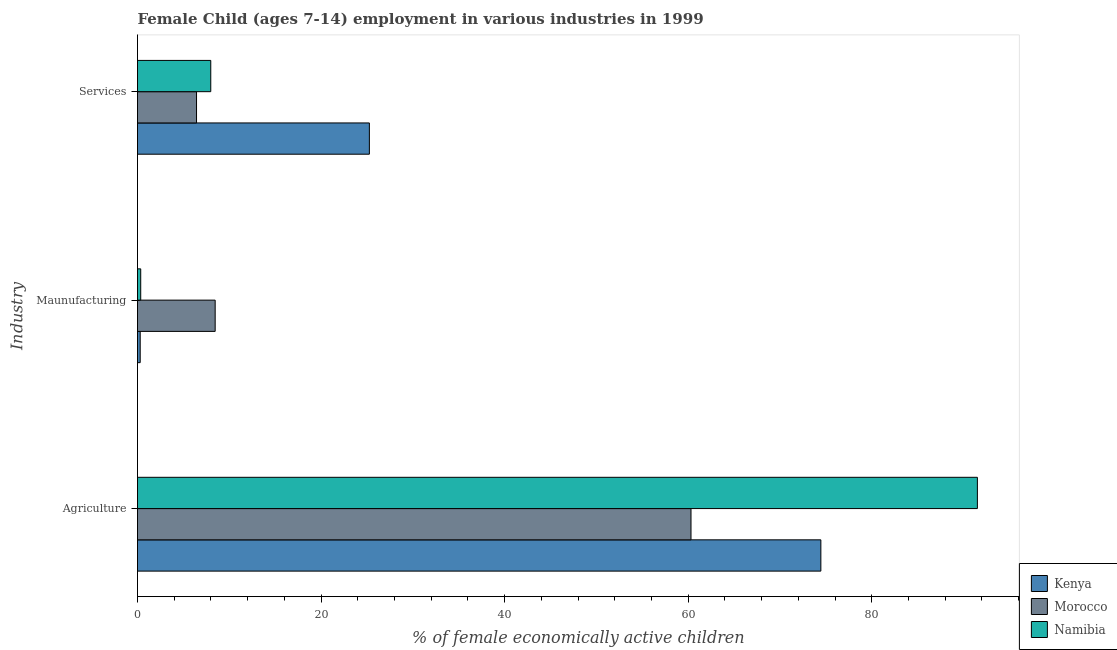How many different coloured bars are there?
Make the answer very short. 3. Are the number of bars on each tick of the Y-axis equal?
Offer a very short reply. Yes. How many bars are there on the 2nd tick from the bottom?
Your answer should be very brief. 3. What is the label of the 3rd group of bars from the top?
Your response must be concise. Agriculture. What is the percentage of economically active children in services in Namibia?
Offer a very short reply. 7.98. Across all countries, what is the maximum percentage of economically active children in manufacturing?
Offer a terse response. 8.46. Across all countries, what is the minimum percentage of economically active children in manufacturing?
Your answer should be compact. 0.29. In which country was the percentage of economically active children in manufacturing maximum?
Your answer should be very brief. Morocco. In which country was the percentage of economically active children in services minimum?
Your answer should be very brief. Morocco. What is the total percentage of economically active children in agriculture in the graph?
Offer a very short reply. 226.25. What is the difference between the percentage of economically active children in manufacturing in Kenya and that in Namibia?
Give a very brief answer. -0.06. What is the difference between the percentage of economically active children in services in Namibia and the percentage of economically active children in agriculture in Morocco?
Your response must be concise. -52.32. What is the average percentage of economically active children in services per country?
Ensure brevity in your answer.  13.22. What is the difference between the percentage of economically active children in manufacturing and percentage of economically active children in services in Kenya?
Offer a terse response. -24.97. What is the ratio of the percentage of economically active children in manufacturing in Kenya to that in Namibia?
Provide a short and direct response. 0.84. Is the difference between the percentage of economically active children in services in Kenya and Namibia greater than the difference between the percentage of economically active children in agriculture in Kenya and Namibia?
Offer a very short reply. Yes. What is the difference between the highest and the second highest percentage of economically active children in services?
Offer a very short reply. 17.28. What is the difference between the highest and the lowest percentage of economically active children in manufacturing?
Give a very brief answer. 8.17. Is the sum of the percentage of economically active children in services in Kenya and Morocco greater than the maximum percentage of economically active children in manufacturing across all countries?
Offer a very short reply. Yes. What does the 3rd bar from the top in Agriculture represents?
Your answer should be very brief. Kenya. What does the 1st bar from the bottom in Services represents?
Provide a short and direct response. Kenya. Is it the case that in every country, the sum of the percentage of economically active children in agriculture and percentage of economically active children in manufacturing is greater than the percentage of economically active children in services?
Ensure brevity in your answer.  Yes. How many bars are there?
Offer a terse response. 9. Are all the bars in the graph horizontal?
Keep it short and to the point. Yes. How many countries are there in the graph?
Keep it short and to the point. 3. What is the difference between two consecutive major ticks on the X-axis?
Keep it short and to the point. 20. Are the values on the major ticks of X-axis written in scientific E-notation?
Keep it short and to the point. No. How many legend labels are there?
Give a very brief answer. 3. What is the title of the graph?
Your answer should be compact. Female Child (ages 7-14) employment in various industries in 1999. What is the label or title of the X-axis?
Your response must be concise. % of female economically active children. What is the label or title of the Y-axis?
Provide a succinct answer. Industry. What is the % of female economically active children of Kenya in Agriculture?
Your answer should be very brief. 74.45. What is the % of female economically active children of Morocco in Agriculture?
Offer a very short reply. 60.3. What is the % of female economically active children in Namibia in Agriculture?
Provide a short and direct response. 91.5. What is the % of female economically active children of Kenya in Maunufacturing?
Provide a short and direct response. 0.29. What is the % of female economically active children of Morocco in Maunufacturing?
Keep it short and to the point. 8.46. What is the % of female economically active children of Kenya in Services?
Your response must be concise. 25.26. What is the % of female economically active children in Morocco in Services?
Keep it short and to the point. 6.43. What is the % of female economically active children of Namibia in Services?
Give a very brief answer. 7.98. Across all Industry, what is the maximum % of female economically active children in Kenya?
Make the answer very short. 74.45. Across all Industry, what is the maximum % of female economically active children of Morocco?
Provide a short and direct response. 60.3. Across all Industry, what is the maximum % of female economically active children in Namibia?
Make the answer very short. 91.5. Across all Industry, what is the minimum % of female economically active children of Kenya?
Offer a very short reply. 0.29. Across all Industry, what is the minimum % of female economically active children in Morocco?
Keep it short and to the point. 6.43. Across all Industry, what is the minimum % of female economically active children in Namibia?
Offer a terse response. 0.35. What is the total % of female economically active children in Morocco in the graph?
Make the answer very short. 75.19. What is the total % of female economically active children of Namibia in the graph?
Your answer should be compact. 99.83. What is the difference between the % of female economically active children of Kenya in Agriculture and that in Maunufacturing?
Keep it short and to the point. 74.15. What is the difference between the % of female economically active children in Morocco in Agriculture and that in Maunufacturing?
Give a very brief answer. 51.84. What is the difference between the % of female economically active children of Namibia in Agriculture and that in Maunufacturing?
Your answer should be compact. 91.15. What is the difference between the % of female economically active children of Kenya in Agriculture and that in Services?
Give a very brief answer. 49.19. What is the difference between the % of female economically active children in Morocco in Agriculture and that in Services?
Keep it short and to the point. 53.87. What is the difference between the % of female economically active children of Namibia in Agriculture and that in Services?
Offer a terse response. 83.52. What is the difference between the % of female economically active children in Kenya in Maunufacturing and that in Services?
Make the answer very short. -24.97. What is the difference between the % of female economically active children of Morocco in Maunufacturing and that in Services?
Make the answer very short. 2.03. What is the difference between the % of female economically active children of Namibia in Maunufacturing and that in Services?
Your answer should be very brief. -7.63. What is the difference between the % of female economically active children in Kenya in Agriculture and the % of female economically active children in Morocco in Maunufacturing?
Make the answer very short. 65.99. What is the difference between the % of female economically active children in Kenya in Agriculture and the % of female economically active children in Namibia in Maunufacturing?
Your response must be concise. 74.1. What is the difference between the % of female economically active children of Morocco in Agriculture and the % of female economically active children of Namibia in Maunufacturing?
Make the answer very short. 59.95. What is the difference between the % of female economically active children of Kenya in Agriculture and the % of female economically active children of Morocco in Services?
Give a very brief answer. 68.02. What is the difference between the % of female economically active children in Kenya in Agriculture and the % of female economically active children in Namibia in Services?
Offer a terse response. 66.47. What is the difference between the % of female economically active children in Morocco in Agriculture and the % of female economically active children in Namibia in Services?
Your response must be concise. 52.32. What is the difference between the % of female economically active children of Kenya in Maunufacturing and the % of female economically active children of Morocco in Services?
Your answer should be very brief. -6.14. What is the difference between the % of female economically active children in Kenya in Maunufacturing and the % of female economically active children in Namibia in Services?
Offer a terse response. -7.69. What is the difference between the % of female economically active children of Morocco in Maunufacturing and the % of female economically active children of Namibia in Services?
Your answer should be compact. 0.48. What is the average % of female economically active children of Kenya per Industry?
Ensure brevity in your answer.  33.33. What is the average % of female economically active children in Morocco per Industry?
Provide a succinct answer. 25.06. What is the average % of female economically active children in Namibia per Industry?
Your response must be concise. 33.28. What is the difference between the % of female economically active children of Kenya and % of female economically active children of Morocco in Agriculture?
Provide a succinct answer. 14.15. What is the difference between the % of female economically active children of Kenya and % of female economically active children of Namibia in Agriculture?
Keep it short and to the point. -17.05. What is the difference between the % of female economically active children of Morocco and % of female economically active children of Namibia in Agriculture?
Your answer should be very brief. -31.2. What is the difference between the % of female economically active children of Kenya and % of female economically active children of Morocco in Maunufacturing?
Make the answer very short. -8.17. What is the difference between the % of female economically active children of Kenya and % of female economically active children of Namibia in Maunufacturing?
Your answer should be very brief. -0.06. What is the difference between the % of female economically active children of Morocco and % of female economically active children of Namibia in Maunufacturing?
Offer a terse response. 8.11. What is the difference between the % of female economically active children of Kenya and % of female economically active children of Morocco in Services?
Offer a terse response. 18.83. What is the difference between the % of female economically active children of Kenya and % of female economically active children of Namibia in Services?
Provide a succinct answer. 17.28. What is the difference between the % of female economically active children in Morocco and % of female economically active children in Namibia in Services?
Your answer should be very brief. -1.55. What is the ratio of the % of female economically active children in Kenya in Agriculture to that in Maunufacturing?
Offer a terse response. 253.97. What is the ratio of the % of female economically active children in Morocco in Agriculture to that in Maunufacturing?
Your answer should be compact. 7.13. What is the ratio of the % of female economically active children of Namibia in Agriculture to that in Maunufacturing?
Give a very brief answer. 261.43. What is the ratio of the % of female economically active children of Kenya in Agriculture to that in Services?
Give a very brief answer. 2.95. What is the ratio of the % of female economically active children in Morocco in Agriculture to that in Services?
Make the answer very short. 9.38. What is the ratio of the % of female economically active children of Namibia in Agriculture to that in Services?
Keep it short and to the point. 11.47. What is the ratio of the % of female economically active children of Kenya in Maunufacturing to that in Services?
Keep it short and to the point. 0.01. What is the ratio of the % of female economically active children in Morocco in Maunufacturing to that in Services?
Ensure brevity in your answer.  1.32. What is the ratio of the % of female economically active children in Namibia in Maunufacturing to that in Services?
Provide a succinct answer. 0.04. What is the difference between the highest and the second highest % of female economically active children in Kenya?
Offer a very short reply. 49.19. What is the difference between the highest and the second highest % of female economically active children of Morocco?
Your answer should be very brief. 51.84. What is the difference between the highest and the second highest % of female economically active children in Namibia?
Your answer should be very brief. 83.52. What is the difference between the highest and the lowest % of female economically active children of Kenya?
Make the answer very short. 74.15. What is the difference between the highest and the lowest % of female economically active children of Morocco?
Keep it short and to the point. 53.87. What is the difference between the highest and the lowest % of female economically active children in Namibia?
Offer a very short reply. 91.15. 